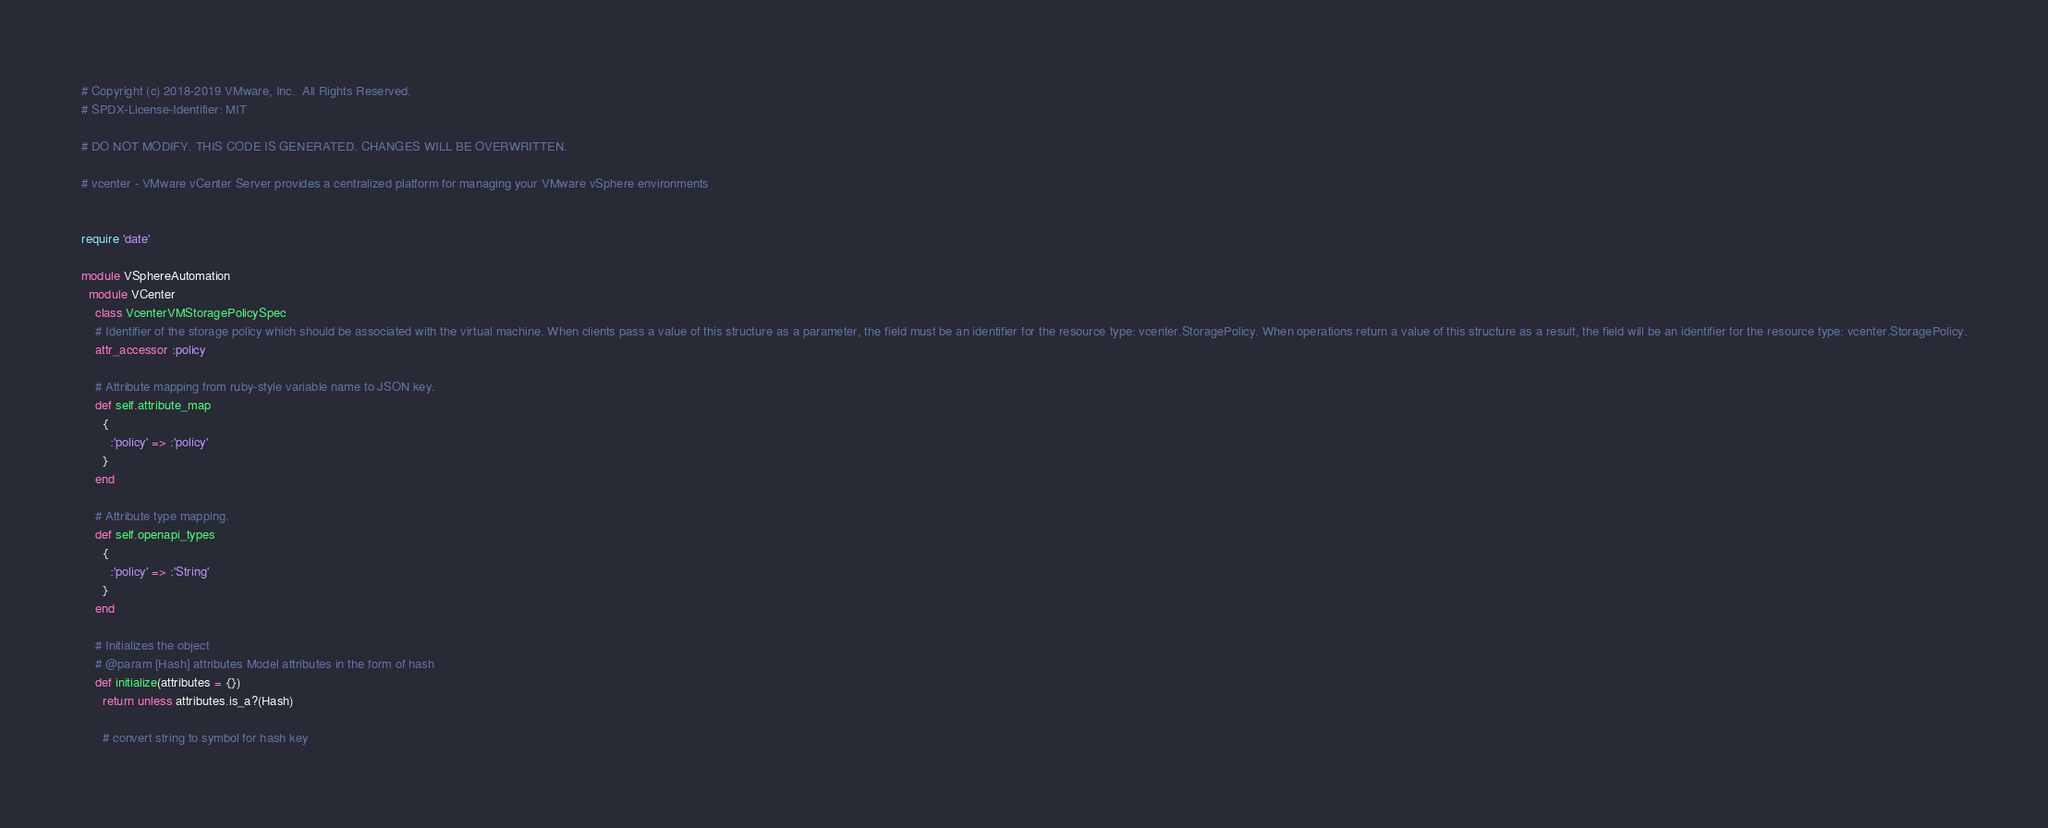<code> <loc_0><loc_0><loc_500><loc_500><_Ruby_># Copyright (c) 2018-2019 VMware, Inc.  All Rights Reserved.
# SPDX-License-Identifier: MIT

# DO NOT MODIFY. THIS CODE IS GENERATED. CHANGES WILL BE OVERWRITTEN.

# vcenter - VMware vCenter Server provides a centralized platform for managing your VMware vSphere environments


require 'date'

module VSphereAutomation
  module VCenter
    class VcenterVMStoragePolicySpec
    # Identifier of the storage policy which should be associated with the virtual machine. When clients pass a value of this structure as a parameter, the field must be an identifier for the resource type: vcenter.StoragePolicy. When operations return a value of this structure as a result, the field will be an identifier for the resource type: vcenter.StoragePolicy.
    attr_accessor :policy

    # Attribute mapping from ruby-style variable name to JSON key.
    def self.attribute_map
      {
        :'policy' => :'policy'
      }
    end

    # Attribute type mapping.
    def self.openapi_types
      {
        :'policy' => :'String'
      }
    end

    # Initializes the object
    # @param [Hash] attributes Model attributes in the form of hash
    def initialize(attributes = {})
      return unless attributes.is_a?(Hash)

      # convert string to symbol for hash key</code> 